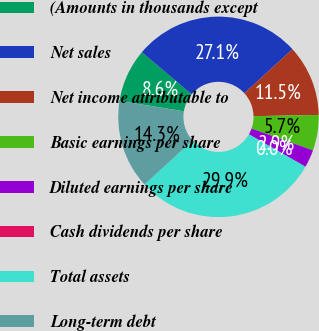Convert chart to OTSL. <chart><loc_0><loc_0><loc_500><loc_500><pie_chart><fcel>(Amounts in thousands except<fcel>Net sales<fcel>Net income attributable to<fcel>Basic earnings per share<fcel>Diluted earnings per share<fcel>Cash dividends per share<fcel>Total assets<fcel>Long-term debt<nl><fcel>8.6%<fcel>27.06%<fcel>11.47%<fcel>5.73%<fcel>2.87%<fcel>0.0%<fcel>29.93%<fcel>14.33%<nl></chart> 